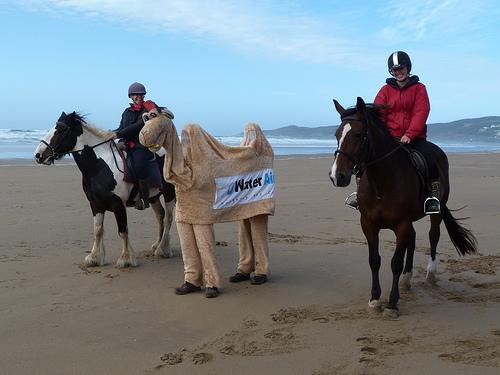Which type of animal is featured alongside the horses in the image? A fake camel made by two people wearing a camel costume. What type of advertisement is seen on the fake camel's side? A white, black, and blue sign. Describe the appearance of the footprints in the sand. The footprints are scattered, deep, and cover a wide area of the beach sand. What can be seen in the distance behind the horses and the fake camel? Mountains, hills, and ocean can be seen in the distance. Can you tell me the primary activity happening in the image? People are riding horses and interacting with a fake camel on a beach. What color is the sky in the picture, and can you see any clouds? The sky is blue and has light clouds. What color are the horses seen in the image? The horses are brown and white in color. List three distinct features of the image. Horses being ridden on the beach, people dressed as a camel, and distant mountains. How many people can be seen riding horses in the picture? At least two people are seen riding horses. What are the two people in the camel costume wearing on their feet? The two people in the camel costume are wearing dark shoes. Choose the correct description of the horse from these options: A) A horse with pink and green stripes B) A beautiful brown and white horse C) A black horse with a yellow mane B) A beautiful brown and white horse Can you spot the green mountains in the distance? There are mountains and hills mentioned in the distance, but their colors are not specified, so it's misleading to ask for green mountains. Provide a description of the ocean in the image. The ocean is blue in color and lies in the distance. Is the girl in the blue jacket riding a horse on the beach? There's a girl in a red jacket riding a horse on the beach, but there's no mention of a girl in a blue jacket. Do you see a dog running alongside the horses on the beach? There is no mention of any dogs in the captions, so asking about a dog is misleading. Are there any footprints from the horses in the sand? While there are footprints and disturbed sand mentioned, they are not explicitly connected to the horses, so asking for horse footprints is misleading. Describe the activity taking place on the beach in the image. People riding horses, two people wearing a camel costume, footprints on the sand, and ocean in the distance. Please identify and describe the animal-related costume in the image. A camel costume worn by two people, brown in color with a white, black, and blue sign on its side. Can you find the yellow sign on the fake camel? There is a white, black, and blue sign mentioned on the fake camel, but not a yellow one. Asking for a yellow sign is misleading. How many people can be seen riding horses in the image? Two people Explain what the two people disguised as a camel are doing. They are standing on the beach, wearing dark shoes and a tan camel costume. What color is the sky in the image? Blue Based on the image, can we infer the weather conditions during this event? It appears to be a calm day with blue sky, light clouds, and no visible strong winds. Determine if any new element that doesn't belong to the beach has been introduced. Yes, there is a fake camel with two people wearing the costume. List the colors of the horses in the image. Brown, white, dark brown, black and white. Is there a rider wearing a helmet in the image? If so, describe its color. Yes, a person is wearing a dark helmet with a white stripe. Identify any footwear seen in the image. Two pairs of dark shoes Where is the person riding a bicycle on the beach? There are people riding horses and a fake camel in the image, but no mention of anyone riding a bicycle. What is the landscape in the distance behind the people and horses? Mountains or hills and ocean What is the main activity the people are doing at the beach? Riding horses Using the image, answer whether there are any advertisements present. Yes, there is an advertisement on the side of the fake camel. Describe the scene involving horses and people. People riding horses on a beach, including a girl in a red jacket and a person using stirrups on a saddle. Are there any footprints on the beach? Yes, there are footprints on the sand. Mention the color of the advertisement present on the image. White, black, and blue Select the most accurate description of the fake camel's appearance from these options: A) The fake camel is bright red B) The fake camel has a purple mane C) The fake camel is brown and has a side advertisement. C) The fake camel is brown and has a side advertisement 